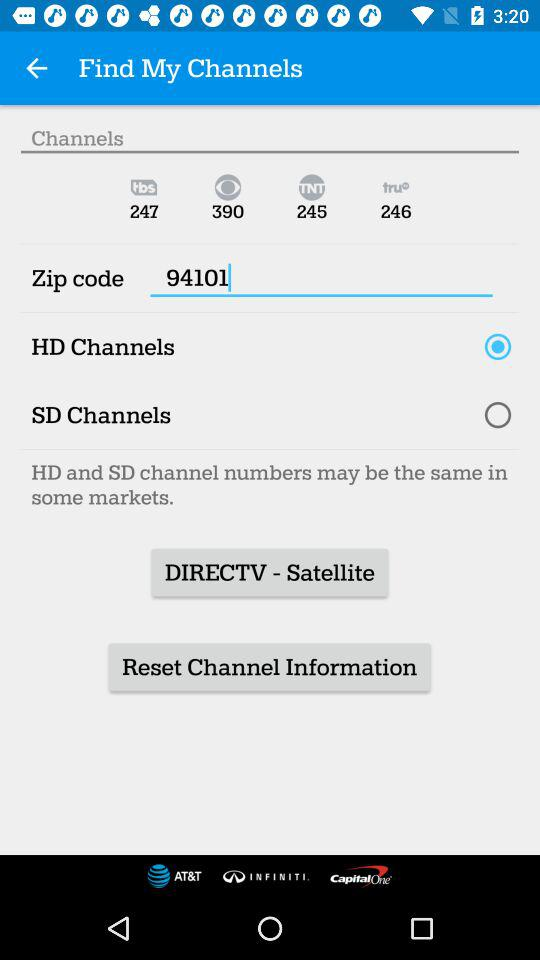What is the zip code? The zip code is 94101. 